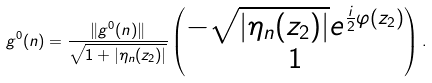<formula> <loc_0><loc_0><loc_500><loc_500>g ^ { 0 } ( n ) = \frac { \| g ^ { 0 } ( n ) \| } { \sqrt { 1 + | \eta _ { n } ( z _ { 2 } ) | } } \begin{pmatrix} - \sqrt { | \eta _ { n } ( z _ { 2 } ) | } e ^ { \frac { i } { 2 } \varphi ( z _ { 2 } ) } \\ 1 \end{pmatrix} .</formula> 